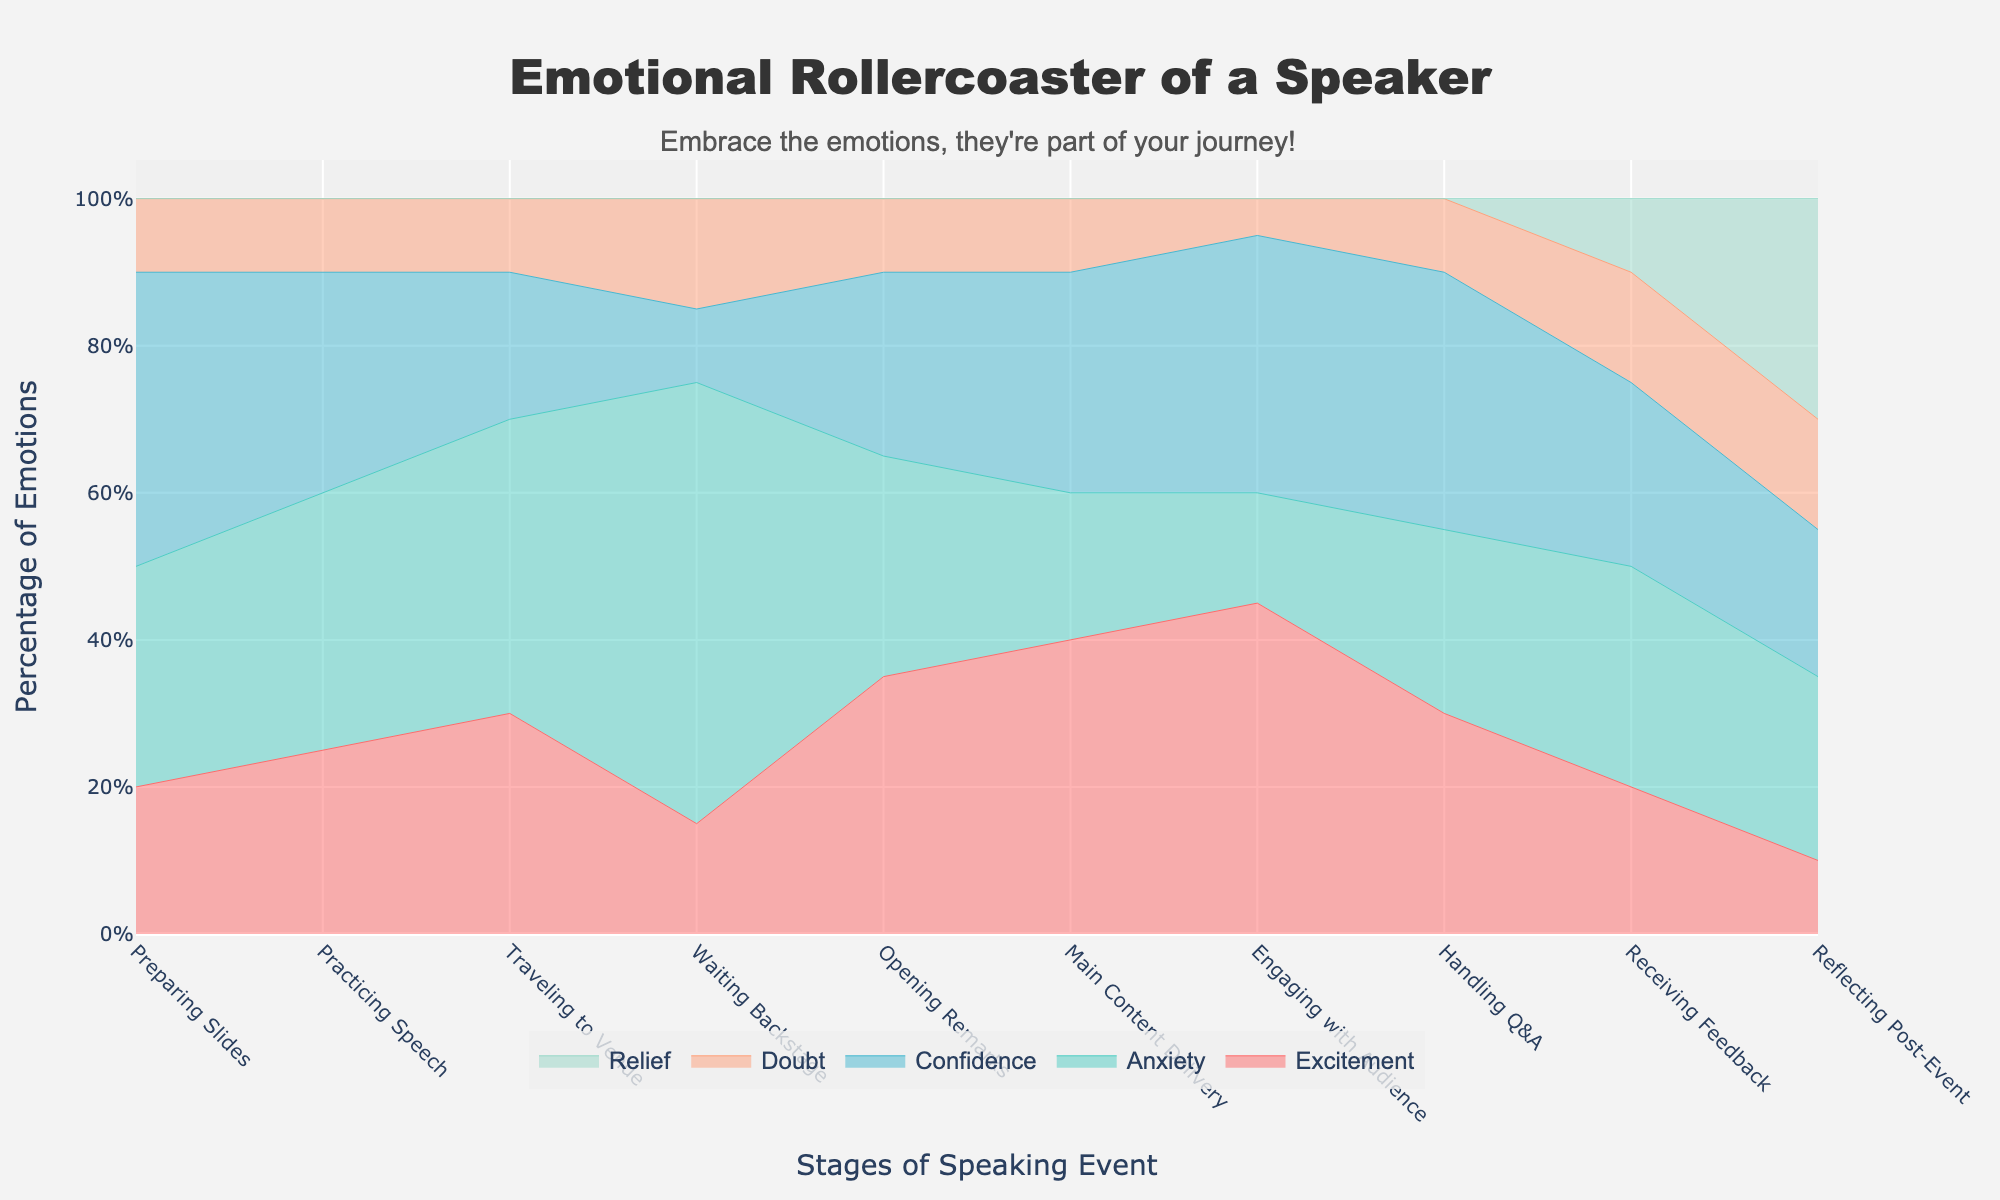What is the title of the plot? The title of the plot is displayed prominently at the top and reads "Emotional Rollercoaster of a Speaker."
Answer: Emotional Rollercoaster of a Speaker During which stage is the speaker's anxiety at its peak? Looking at the plot, anxiety peaks during the "Waiting Backstage" stage, as this segment takes up the largest space within the anxiety category at this stage.
Answer: Waiting Backstage Which emotion reaches the highest percentage during the "Reflecting Post-Event" stage? The "Reflecting Post-Event" stage shows that the emotion 'Relief' reaches its highest percentage, filling the topmost and broadest part of the area chart for this stage.
Answer: Relief How does the level of confidence change from "Practicing Speech" to "Handling Q&A"? Observing the plot, confidence starts at 30% during "Practicing Speech" and rises to 35% in "Handling Q&A". This shows an increase of 5% in confidence.
Answer: It increases Which stage has the least excitement? The excitement level is the smallest during the "Waiting Backstage" stage, where it occupies the smallest portion of the stack when compared to other stages.
Answer: Waiting Backstage How do the relief percentages vary between "Receiving Feedback" and "Reflecting Post-Event"? Relief shows an increase from the "Receiving Feedback" stage (where it is at 10%) to the "Reflecting Post-Event" stage (where it reaches 30%).
Answer: They increase Is the percentage of doubt consistently high or low throughout the stages? Doubt remains relatively low, never exceeding 15%, at any stage of the speaking event. The pattern shows it remains fairly constant.
Answer: Low What is the overall trend of excitement from "Preparing Slides" to "Engaging with Audience"? Excitement starts at 20% during "Preparing Slides" and steadily rises, peaking at 45% during "Engaging with Audience", showing an upward trajectory overall.
Answer: Increasing Which two emotions make up the largest share of the speaker's emotional state while "Waiting Backstage"? Anxiety and doubt combined take over the emotional state at "Waiting Backstage", with anxiety at 60% and doubt at 15%, making these the largest share at this stage.
Answer: Anxiety and Doubt 